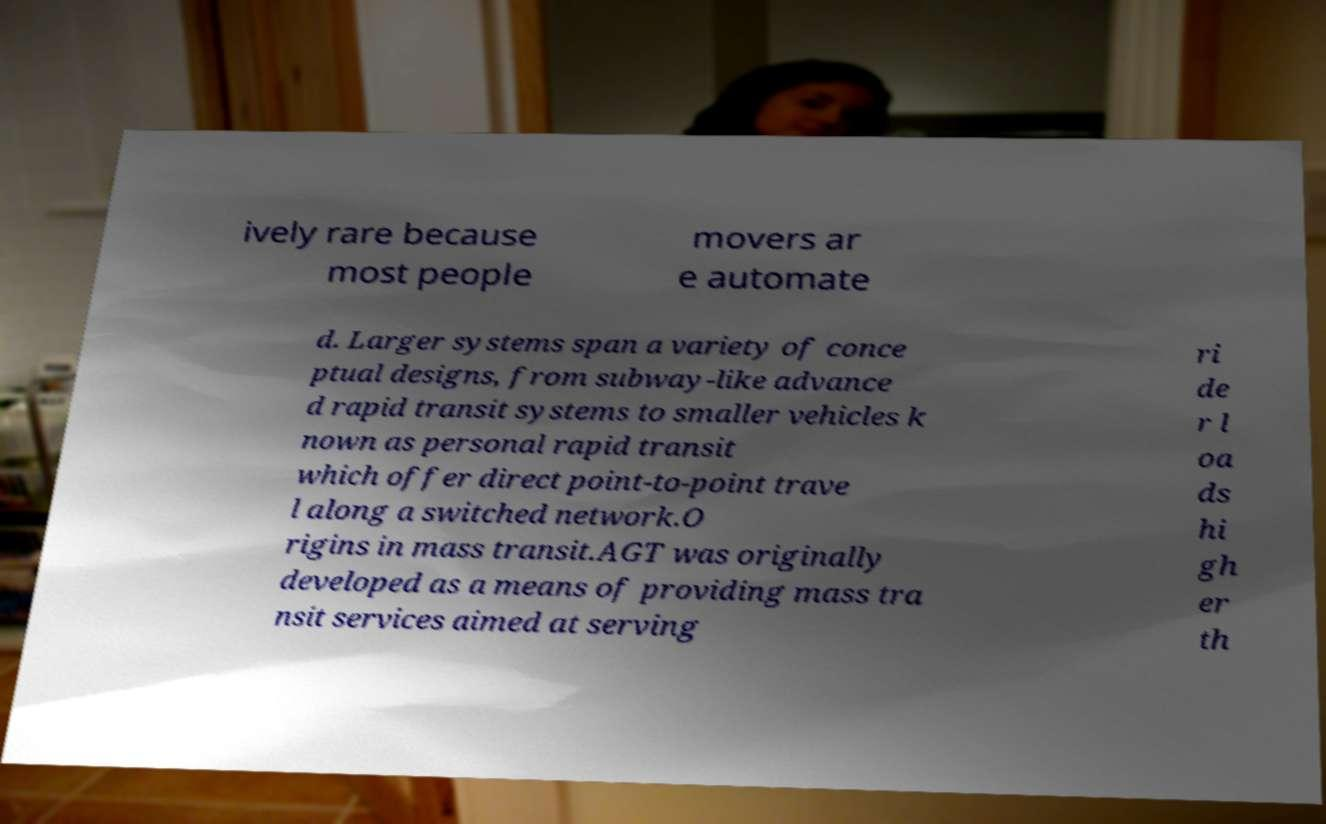What messages or text are displayed in this image? I need them in a readable, typed format. ively rare because most people movers ar e automate d. Larger systems span a variety of conce ptual designs, from subway-like advance d rapid transit systems to smaller vehicles k nown as personal rapid transit which offer direct point-to-point trave l along a switched network.O rigins in mass transit.AGT was originally developed as a means of providing mass tra nsit services aimed at serving ri de r l oa ds hi gh er th 